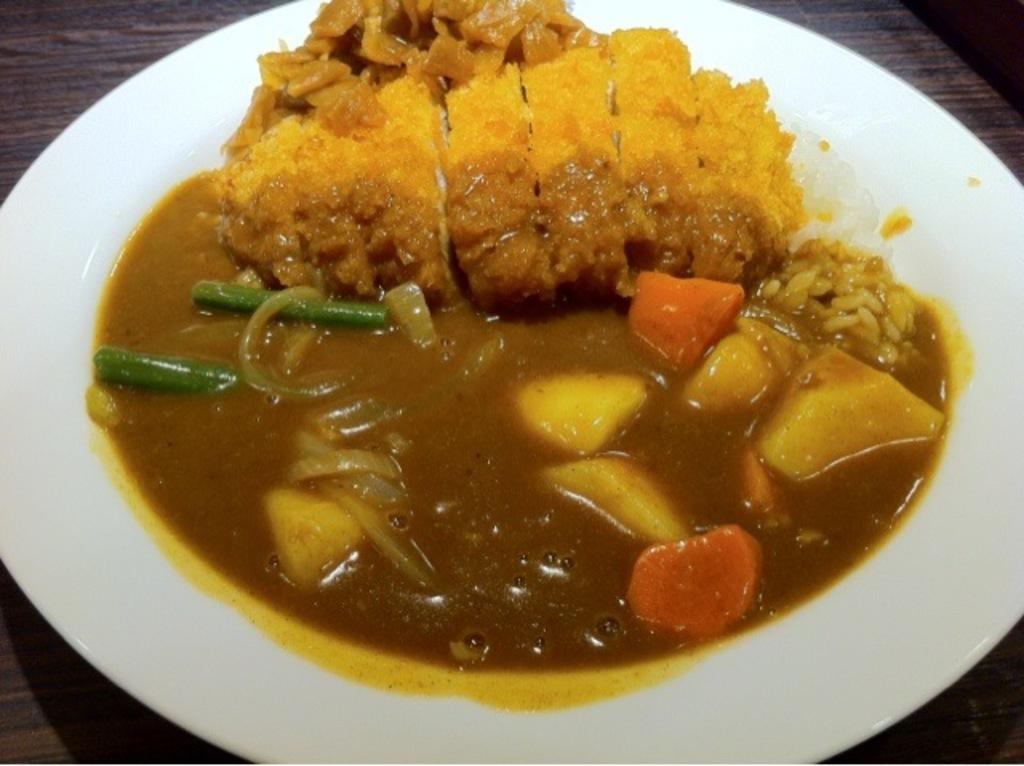Can you describe this image briefly? In this image I can see there is some food places in the plate and it is placed on the wooden table. 